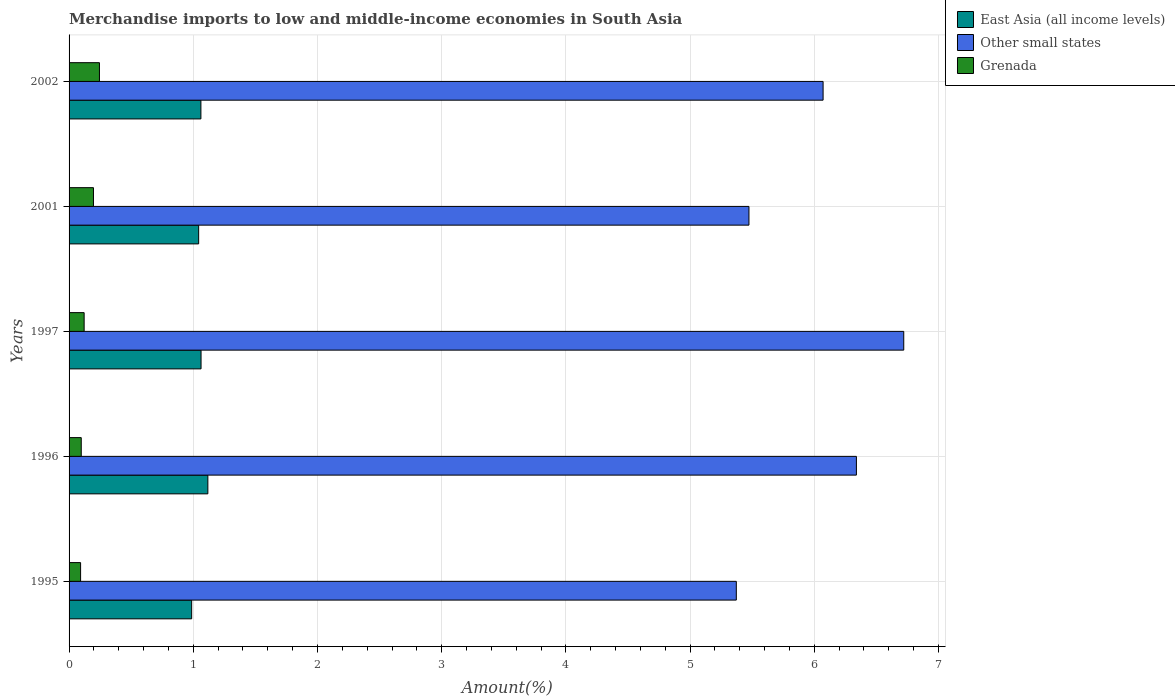Are the number of bars per tick equal to the number of legend labels?
Your answer should be compact. Yes. How many bars are there on the 4th tick from the top?
Your answer should be compact. 3. How many bars are there on the 1st tick from the bottom?
Offer a very short reply. 3. What is the label of the 1st group of bars from the top?
Offer a terse response. 2002. In how many cases, is the number of bars for a given year not equal to the number of legend labels?
Provide a short and direct response. 0. What is the percentage of amount earned from merchandise imports in Grenada in 1997?
Your answer should be compact. 0.12. Across all years, what is the maximum percentage of amount earned from merchandise imports in Grenada?
Give a very brief answer. 0.24. Across all years, what is the minimum percentage of amount earned from merchandise imports in Grenada?
Your answer should be very brief. 0.09. In which year was the percentage of amount earned from merchandise imports in Grenada maximum?
Offer a very short reply. 2002. What is the total percentage of amount earned from merchandise imports in Grenada in the graph?
Your response must be concise. 0.75. What is the difference between the percentage of amount earned from merchandise imports in Other small states in 1995 and that in 2002?
Ensure brevity in your answer.  -0.7. What is the difference between the percentage of amount earned from merchandise imports in Other small states in 1997 and the percentage of amount earned from merchandise imports in Grenada in 1995?
Make the answer very short. 6.63. What is the average percentage of amount earned from merchandise imports in East Asia (all income levels) per year?
Keep it short and to the point. 1.05. In the year 1996, what is the difference between the percentage of amount earned from merchandise imports in Grenada and percentage of amount earned from merchandise imports in East Asia (all income levels)?
Ensure brevity in your answer.  -1.02. What is the ratio of the percentage of amount earned from merchandise imports in Grenada in 1997 to that in 2002?
Offer a terse response. 0.5. What is the difference between the highest and the second highest percentage of amount earned from merchandise imports in East Asia (all income levels)?
Make the answer very short. 0.05. What is the difference between the highest and the lowest percentage of amount earned from merchandise imports in East Asia (all income levels)?
Make the answer very short. 0.13. In how many years, is the percentage of amount earned from merchandise imports in East Asia (all income levels) greater than the average percentage of amount earned from merchandise imports in East Asia (all income levels) taken over all years?
Give a very brief answer. 3. Is the sum of the percentage of amount earned from merchandise imports in Grenada in 1995 and 2002 greater than the maximum percentage of amount earned from merchandise imports in Other small states across all years?
Provide a succinct answer. No. What does the 3rd bar from the top in 1996 represents?
Your response must be concise. East Asia (all income levels). What does the 3rd bar from the bottom in 2001 represents?
Offer a very short reply. Grenada. How many bars are there?
Offer a very short reply. 15. Are all the bars in the graph horizontal?
Keep it short and to the point. Yes. How many years are there in the graph?
Provide a short and direct response. 5. Are the values on the major ticks of X-axis written in scientific E-notation?
Offer a very short reply. No. What is the title of the graph?
Make the answer very short. Merchandise imports to low and middle-income economies in South Asia. Does "Europe(developing only)" appear as one of the legend labels in the graph?
Offer a very short reply. No. What is the label or title of the X-axis?
Keep it short and to the point. Amount(%). What is the label or title of the Y-axis?
Offer a very short reply. Years. What is the Amount(%) of East Asia (all income levels) in 1995?
Provide a succinct answer. 0.99. What is the Amount(%) of Other small states in 1995?
Ensure brevity in your answer.  5.37. What is the Amount(%) in Grenada in 1995?
Provide a succinct answer. 0.09. What is the Amount(%) in East Asia (all income levels) in 1996?
Your response must be concise. 1.12. What is the Amount(%) of Other small states in 1996?
Your response must be concise. 6.34. What is the Amount(%) of Grenada in 1996?
Offer a very short reply. 0.1. What is the Amount(%) of East Asia (all income levels) in 1997?
Keep it short and to the point. 1.06. What is the Amount(%) in Other small states in 1997?
Offer a terse response. 6.72. What is the Amount(%) of Grenada in 1997?
Ensure brevity in your answer.  0.12. What is the Amount(%) of East Asia (all income levels) in 2001?
Offer a very short reply. 1.04. What is the Amount(%) of Other small states in 2001?
Ensure brevity in your answer.  5.47. What is the Amount(%) of Grenada in 2001?
Provide a short and direct response. 0.2. What is the Amount(%) in East Asia (all income levels) in 2002?
Provide a succinct answer. 1.06. What is the Amount(%) of Other small states in 2002?
Give a very brief answer. 6.07. What is the Amount(%) in Grenada in 2002?
Offer a very short reply. 0.24. Across all years, what is the maximum Amount(%) in East Asia (all income levels)?
Your answer should be very brief. 1.12. Across all years, what is the maximum Amount(%) of Other small states?
Provide a short and direct response. 6.72. Across all years, what is the maximum Amount(%) in Grenada?
Make the answer very short. 0.24. Across all years, what is the minimum Amount(%) of East Asia (all income levels)?
Your answer should be very brief. 0.99. Across all years, what is the minimum Amount(%) of Other small states?
Your response must be concise. 5.37. Across all years, what is the minimum Amount(%) of Grenada?
Provide a succinct answer. 0.09. What is the total Amount(%) of East Asia (all income levels) in the graph?
Your response must be concise. 5.27. What is the total Amount(%) of Other small states in the graph?
Give a very brief answer. 29.98. What is the total Amount(%) in Grenada in the graph?
Provide a short and direct response. 0.75. What is the difference between the Amount(%) in East Asia (all income levels) in 1995 and that in 1996?
Provide a short and direct response. -0.13. What is the difference between the Amount(%) in Other small states in 1995 and that in 1996?
Give a very brief answer. -0.97. What is the difference between the Amount(%) of Grenada in 1995 and that in 1996?
Make the answer very short. -0.01. What is the difference between the Amount(%) in East Asia (all income levels) in 1995 and that in 1997?
Provide a succinct answer. -0.08. What is the difference between the Amount(%) of Other small states in 1995 and that in 1997?
Offer a very short reply. -1.35. What is the difference between the Amount(%) in Grenada in 1995 and that in 1997?
Your response must be concise. -0.03. What is the difference between the Amount(%) in East Asia (all income levels) in 1995 and that in 2001?
Make the answer very short. -0.06. What is the difference between the Amount(%) in Other small states in 1995 and that in 2001?
Your response must be concise. -0.1. What is the difference between the Amount(%) of Grenada in 1995 and that in 2001?
Your response must be concise. -0.1. What is the difference between the Amount(%) in East Asia (all income levels) in 1995 and that in 2002?
Your response must be concise. -0.07. What is the difference between the Amount(%) of Other small states in 1995 and that in 2002?
Your answer should be compact. -0.7. What is the difference between the Amount(%) in Grenada in 1995 and that in 2002?
Offer a terse response. -0.15. What is the difference between the Amount(%) in East Asia (all income levels) in 1996 and that in 1997?
Offer a terse response. 0.05. What is the difference between the Amount(%) of Other small states in 1996 and that in 1997?
Provide a short and direct response. -0.38. What is the difference between the Amount(%) in Grenada in 1996 and that in 1997?
Keep it short and to the point. -0.02. What is the difference between the Amount(%) of East Asia (all income levels) in 1996 and that in 2001?
Your response must be concise. 0.07. What is the difference between the Amount(%) in Other small states in 1996 and that in 2001?
Make the answer very short. 0.87. What is the difference between the Amount(%) in Grenada in 1996 and that in 2001?
Keep it short and to the point. -0.1. What is the difference between the Amount(%) of East Asia (all income levels) in 1996 and that in 2002?
Offer a terse response. 0.06. What is the difference between the Amount(%) in Other small states in 1996 and that in 2002?
Your answer should be compact. 0.27. What is the difference between the Amount(%) in Grenada in 1996 and that in 2002?
Ensure brevity in your answer.  -0.15. What is the difference between the Amount(%) in East Asia (all income levels) in 1997 and that in 2001?
Give a very brief answer. 0.02. What is the difference between the Amount(%) in Other small states in 1997 and that in 2001?
Offer a terse response. 1.25. What is the difference between the Amount(%) in Grenada in 1997 and that in 2001?
Provide a succinct answer. -0.08. What is the difference between the Amount(%) in East Asia (all income levels) in 1997 and that in 2002?
Ensure brevity in your answer.  0. What is the difference between the Amount(%) of Other small states in 1997 and that in 2002?
Make the answer very short. 0.65. What is the difference between the Amount(%) of Grenada in 1997 and that in 2002?
Keep it short and to the point. -0.12. What is the difference between the Amount(%) of East Asia (all income levels) in 2001 and that in 2002?
Your answer should be compact. -0.02. What is the difference between the Amount(%) in Other small states in 2001 and that in 2002?
Your response must be concise. -0.6. What is the difference between the Amount(%) in Grenada in 2001 and that in 2002?
Your answer should be compact. -0.05. What is the difference between the Amount(%) of East Asia (all income levels) in 1995 and the Amount(%) of Other small states in 1996?
Keep it short and to the point. -5.35. What is the difference between the Amount(%) in East Asia (all income levels) in 1995 and the Amount(%) in Grenada in 1996?
Your answer should be compact. 0.89. What is the difference between the Amount(%) in Other small states in 1995 and the Amount(%) in Grenada in 1996?
Provide a short and direct response. 5.27. What is the difference between the Amount(%) of East Asia (all income levels) in 1995 and the Amount(%) of Other small states in 1997?
Provide a short and direct response. -5.73. What is the difference between the Amount(%) in East Asia (all income levels) in 1995 and the Amount(%) in Grenada in 1997?
Offer a terse response. 0.87. What is the difference between the Amount(%) of Other small states in 1995 and the Amount(%) of Grenada in 1997?
Make the answer very short. 5.25. What is the difference between the Amount(%) in East Asia (all income levels) in 1995 and the Amount(%) in Other small states in 2001?
Provide a short and direct response. -4.49. What is the difference between the Amount(%) in East Asia (all income levels) in 1995 and the Amount(%) in Grenada in 2001?
Keep it short and to the point. 0.79. What is the difference between the Amount(%) in Other small states in 1995 and the Amount(%) in Grenada in 2001?
Provide a short and direct response. 5.18. What is the difference between the Amount(%) in East Asia (all income levels) in 1995 and the Amount(%) in Other small states in 2002?
Give a very brief answer. -5.08. What is the difference between the Amount(%) of East Asia (all income levels) in 1995 and the Amount(%) of Grenada in 2002?
Make the answer very short. 0.74. What is the difference between the Amount(%) of Other small states in 1995 and the Amount(%) of Grenada in 2002?
Offer a terse response. 5.13. What is the difference between the Amount(%) in East Asia (all income levels) in 1996 and the Amount(%) in Other small states in 1997?
Keep it short and to the point. -5.6. What is the difference between the Amount(%) in Other small states in 1996 and the Amount(%) in Grenada in 1997?
Provide a succinct answer. 6.22. What is the difference between the Amount(%) of East Asia (all income levels) in 1996 and the Amount(%) of Other small states in 2001?
Keep it short and to the point. -4.36. What is the difference between the Amount(%) of East Asia (all income levels) in 1996 and the Amount(%) of Grenada in 2001?
Your answer should be very brief. 0.92. What is the difference between the Amount(%) in Other small states in 1996 and the Amount(%) in Grenada in 2001?
Give a very brief answer. 6.14. What is the difference between the Amount(%) of East Asia (all income levels) in 1996 and the Amount(%) of Other small states in 2002?
Offer a very short reply. -4.95. What is the difference between the Amount(%) in East Asia (all income levels) in 1996 and the Amount(%) in Grenada in 2002?
Keep it short and to the point. 0.87. What is the difference between the Amount(%) in Other small states in 1996 and the Amount(%) in Grenada in 2002?
Your answer should be compact. 6.09. What is the difference between the Amount(%) in East Asia (all income levels) in 1997 and the Amount(%) in Other small states in 2001?
Your answer should be very brief. -4.41. What is the difference between the Amount(%) in East Asia (all income levels) in 1997 and the Amount(%) in Grenada in 2001?
Keep it short and to the point. 0.87. What is the difference between the Amount(%) of Other small states in 1997 and the Amount(%) of Grenada in 2001?
Offer a very short reply. 6.52. What is the difference between the Amount(%) in East Asia (all income levels) in 1997 and the Amount(%) in Other small states in 2002?
Your answer should be compact. -5.01. What is the difference between the Amount(%) of East Asia (all income levels) in 1997 and the Amount(%) of Grenada in 2002?
Provide a succinct answer. 0.82. What is the difference between the Amount(%) of Other small states in 1997 and the Amount(%) of Grenada in 2002?
Provide a short and direct response. 6.48. What is the difference between the Amount(%) in East Asia (all income levels) in 2001 and the Amount(%) in Other small states in 2002?
Give a very brief answer. -5.03. What is the difference between the Amount(%) of East Asia (all income levels) in 2001 and the Amount(%) of Grenada in 2002?
Provide a short and direct response. 0.8. What is the difference between the Amount(%) of Other small states in 2001 and the Amount(%) of Grenada in 2002?
Ensure brevity in your answer.  5.23. What is the average Amount(%) of East Asia (all income levels) per year?
Your answer should be very brief. 1.05. What is the average Amount(%) in Other small states per year?
Offer a very short reply. 6. What is the average Amount(%) of Grenada per year?
Give a very brief answer. 0.15. In the year 1995, what is the difference between the Amount(%) in East Asia (all income levels) and Amount(%) in Other small states?
Your response must be concise. -4.39. In the year 1995, what is the difference between the Amount(%) in East Asia (all income levels) and Amount(%) in Grenada?
Your response must be concise. 0.89. In the year 1995, what is the difference between the Amount(%) in Other small states and Amount(%) in Grenada?
Your answer should be very brief. 5.28. In the year 1996, what is the difference between the Amount(%) of East Asia (all income levels) and Amount(%) of Other small states?
Offer a terse response. -5.22. In the year 1996, what is the difference between the Amount(%) in East Asia (all income levels) and Amount(%) in Grenada?
Give a very brief answer. 1.02. In the year 1996, what is the difference between the Amount(%) in Other small states and Amount(%) in Grenada?
Keep it short and to the point. 6.24. In the year 1997, what is the difference between the Amount(%) in East Asia (all income levels) and Amount(%) in Other small states?
Keep it short and to the point. -5.66. In the year 1997, what is the difference between the Amount(%) of Other small states and Amount(%) of Grenada?
Keep it short and to the point. 6.6. In the year 2001, what is the difference between the Amount(%) in East Asia (all income levels) and Amount(%) in Other small states?
Provide a succinct answer. -4.43. In the year 2001, what is the difference between the Amount(%) of East Asia (all income levels) and Amount(%) of Grenada?
Provide a succinct answer. 0.85. In the year 2001, what is the difference between the Amount(%) of Other small states and Amount(%) of Grenada?
Make the answer very short. 5.28. In the year 2002, what is the difference between the Amount(%) in East Asia (all income levels) and Amount(%) in Other small states?
Offer a very short reply. -5.01. In the year 2002, what is the difference between the Amount(%) of East Asia (all income levels) and Amount(%) of Grenada?
Keep it short and to the point. 0.82. In the year 2002, what is the difference between the Amount(%) of Other small states and Amount(%) of Grenada?
Make the answer very short. 5.83. What is the ratio of the Amount(%) of East Asia (all income levels) in 1995 to that in 1996?
Your response must be concise. 0.88. What is the ratio of the Amount(%) of Other small states in 1995 to that in 1996?
Offer a terse response. 0.85. What is the ratio of the Amount(%) in Grenada in 1995 to that in 1996?
Offer a terse response. 0.95. What is the ratio of the Amount(%) of East Asia (all income levels) in 1995 to that in 1997?
Provide a short and direct response. 0.93. What is the ratio of the Amount(%) in Other small states in 1995 to that in 1997?
Provide a short and direct response. 0.8. What is the ratio of the Amount(%) of Grenada in 1995 to that in 1997?
Your answer should be very brief. 0.76. What is the ratio of the Amount(%) in East Asia (all income levels) in 1995 to that in 2001?
Provide a short and direct response. 0.95. What is the ratio of the Amount(%) in Other small states in 1995 to that in 2001?
Provide a short and direct response. 0.98. What is the ratio of the Amount(%) of Grenada in 1995 to that in 2001?
Your answer should be compact. 0.47. What is the ratio of the Amount(%) of East Asia (all income levels) in 1995 to that in 2002?
Keep it short and to the point. 0.93. What is the ratio of the Amount(%) in Other small states in 1995 to that in 2002?
Offer a terse response. 0.88. What is the ratio of the Amount(%) of Grenada in 1995 to that in 2002?
Your response must be concise. 0.38. What is the ratio of the Amount(%) of East Asia (all income levels) in 1996 to that in 1997?
Ensure brevity in your answer.  1.05. What is the ratio of the Amount(%) in Other small states in 1996 to that in 1997?
Provide a succinct answer. 0.94. What is the ratio of the Amount(%) in Grenada in 1996 to that in 1997?
Provide a succinct answer. 0.81. What is the ratio of the Amount(%) of East Asia (all income levels) in 1996 to that in 2001?
Ensure brevity in your answer.  1.07. What is the ratio of the Amount(%) of Other small states in 1996 to that in 2001?
Provide a short and direct response. 1.16. What is the ratio of the Amount(%) in Grenada in 1996 to that in 2001?
Make the answer very short. 0.5. What is the ratio of the Amount(%) in East Asia (all income levels) in 1996 to that in 2002?
Your answer should be compact. 1.05. What is the ratio of the Amount(%) in Other small states in 1996 to that in 2002?
Offer a terse response. 1.04. What is the ratio of the Amount(%) in Grenada in 1996 to that in 2002?
Ensure brevity in your answer.  0.4. What is the ratio of the Amount(%) in East Asia (all income levels) in 1997 to that in 2001?
Provide a succinct answer. 1.02. What is the ratio of the Amount(%) in Other small states in 1997 to that in 2001?
Provide a short and direct response. 1.23. What is the ratio of the Amount(%) in Grenada in 1997 to that in 2001?
Make the answer very short. 0.62. What is the ratio of the Amount(%) in East Asia (all income levels) in 1997 to that in 2002?
Make the answer very short. 1. What is the ratio of the Amount(%) of Other small states in 1997 to that in 2002?
Keep it short and to the point. 1.11. What is the ratio of the Amount(%) of Grenada in 1997 to that in 2002?
Your answer should be very brief. 0.5. What is the ratio of the Amount(%) in East Asia (all income levels) in 2001 to that in 2002?
Your answer should be compact. 0.98. What is the ratio of the Amount(%) of Other small states in 2001 to that in 2002?
Your answer should be very brief. 0.9. What is the ratio of the Amount(%) of Grenada in 2001 to that in 2002?
Your response must be concise. 0.8. What is the difference between the highest and the second highest Amount(%) in East Asia (all income levels)?
Provide a short and direct response. 0.05. What is the difference between the highest and the second highest Amount(%) in Other small states?
Give a very brief answer. 0.38. What is the difference between the highest and the second highest Amount(%) in Grenada?
Ensure brevity in your answer.  0.05. What is the difference between the highest and the lowest Amount(%) in East Asia (all income levels)?
Your answer should be very brief. 0.13. What is the difference between the highest and the lowest Amount(%) of Other small states?
Offer a terse response. 1.35. What is the difference between the highest and the lowest Amount(%) of Grenada?
Your answer should be compact. 0.15. 